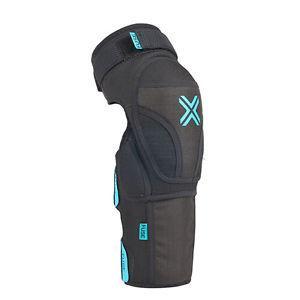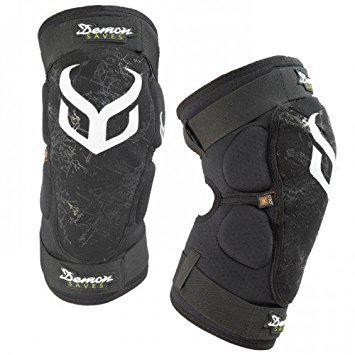The first image is the image on the left, the second image is the image on the right. For the images displayed, is the sentence "The left image contains one kneepad, while the right image contains a pair." factually correct? Answer yes or no. Yes. The first image is the image on the left, the second image is the image on the right. Examine the images to the left and right. Is the description "One pair of guards is incomplete." accurate? Answer yes or no. Yes. 